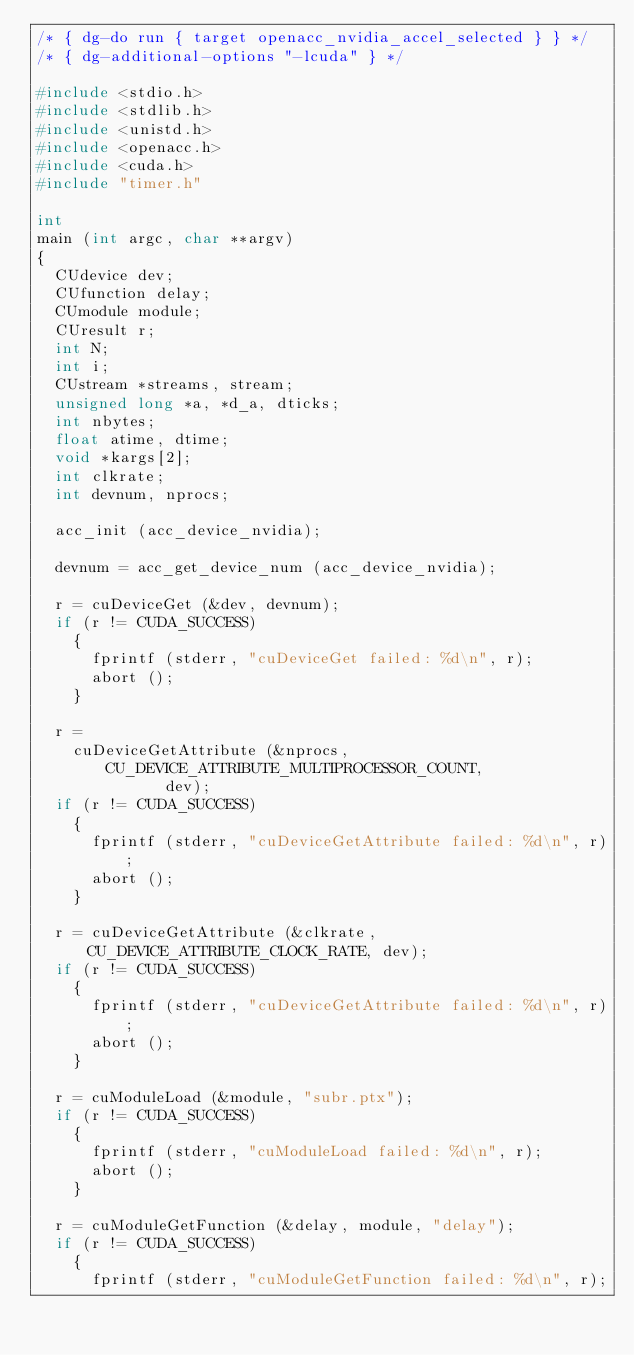Convert code to text. <code><loc_0><loc_0><loc_500><loc_500><_C_>/* { dg-do run { target openacc_nvidia_accel_selected } } */
/* { dg-additional-options "-lcuda" } */

#include <stdio.h>
#include <stdlib.h>
#include <unistd.h>
#include <openacc.h>
#include <cuda.h>
#include "timer.h"

int
main (int argc, char **argv)
{
  CUdevice dev;
  CUfunction delay;
  CUmodule module;
  CUresult r;
  int N;
  int i;
  CUstream *streams, stream;
  unsigned long *a, *d_a, dticks;
  int nbytes;
  float atime, dtime;
  void *kargs[2];
  int clkrate;
  int devnum, nprocs;

  acc_init (acc_device_nvidia);

  devnum = acc_get_device_num (acc_device_nvidia);

  r = cuDeviceGet (&dev, devnum);
  if (r != CUDA_SUCCESS)
    {
      fprintf (stderr, "cuDeviceGet failed: %d\n", r);
      abort ();
    }

  r =
    cuDeviceGetAttribute (&nprocs, CU_DEVICE_ATTRIBUTE_MULTIPROCESSOR_COUNT,
			  dev);
  if (r != CUDA_SUCCESS)
    {
      fprintf (stderr, "cuDeviceGetAttribute failed: %d\n", r);
      abort ();
    }

  r = cuDeviceGetAttribute (&clkrate, CU_DEVICE_ATTRIBUTE_CLOCK_RATE, dev);
  if (r != CUDA_SUCCESS)
    {
      fprintf (stderr, "cuDeviceGetAttribute failed: %d\n", r);
      abort ();
    }

  r = cuModuleLoad (&module, "subr.ptx");
  if (r != CUDA_SUCCESS)
    {
      fprintf (stderr, "cuModuleLoad failed: %d\n", r);
      abort ();
    }

  r = cuModuleGetFunction (&delay, module, "delay");
  if (r != CUDA_SUCCESS)
    {
      fprintf (stderr, "cuModuleGetFunction failed: %d\n", r);</code> 